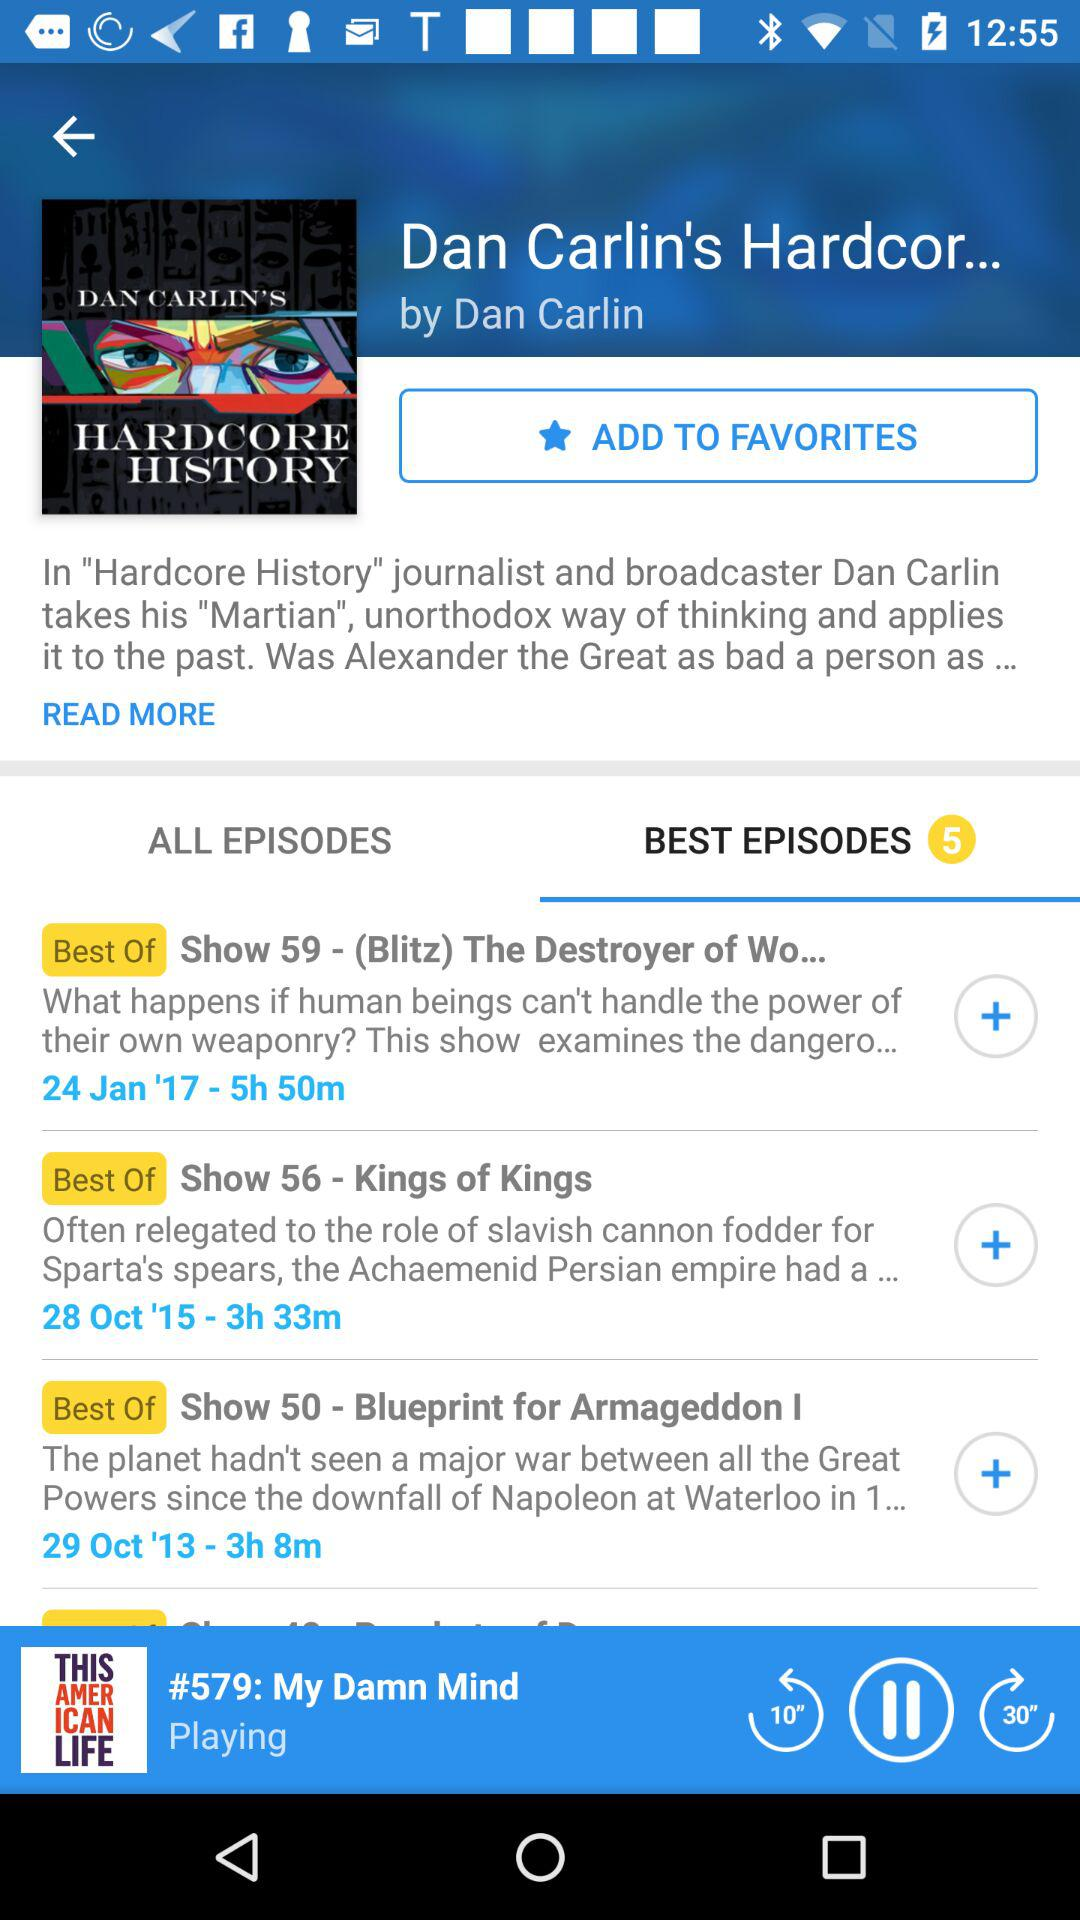Which tab is selected? The selected tab is "BEST EPISODES". 